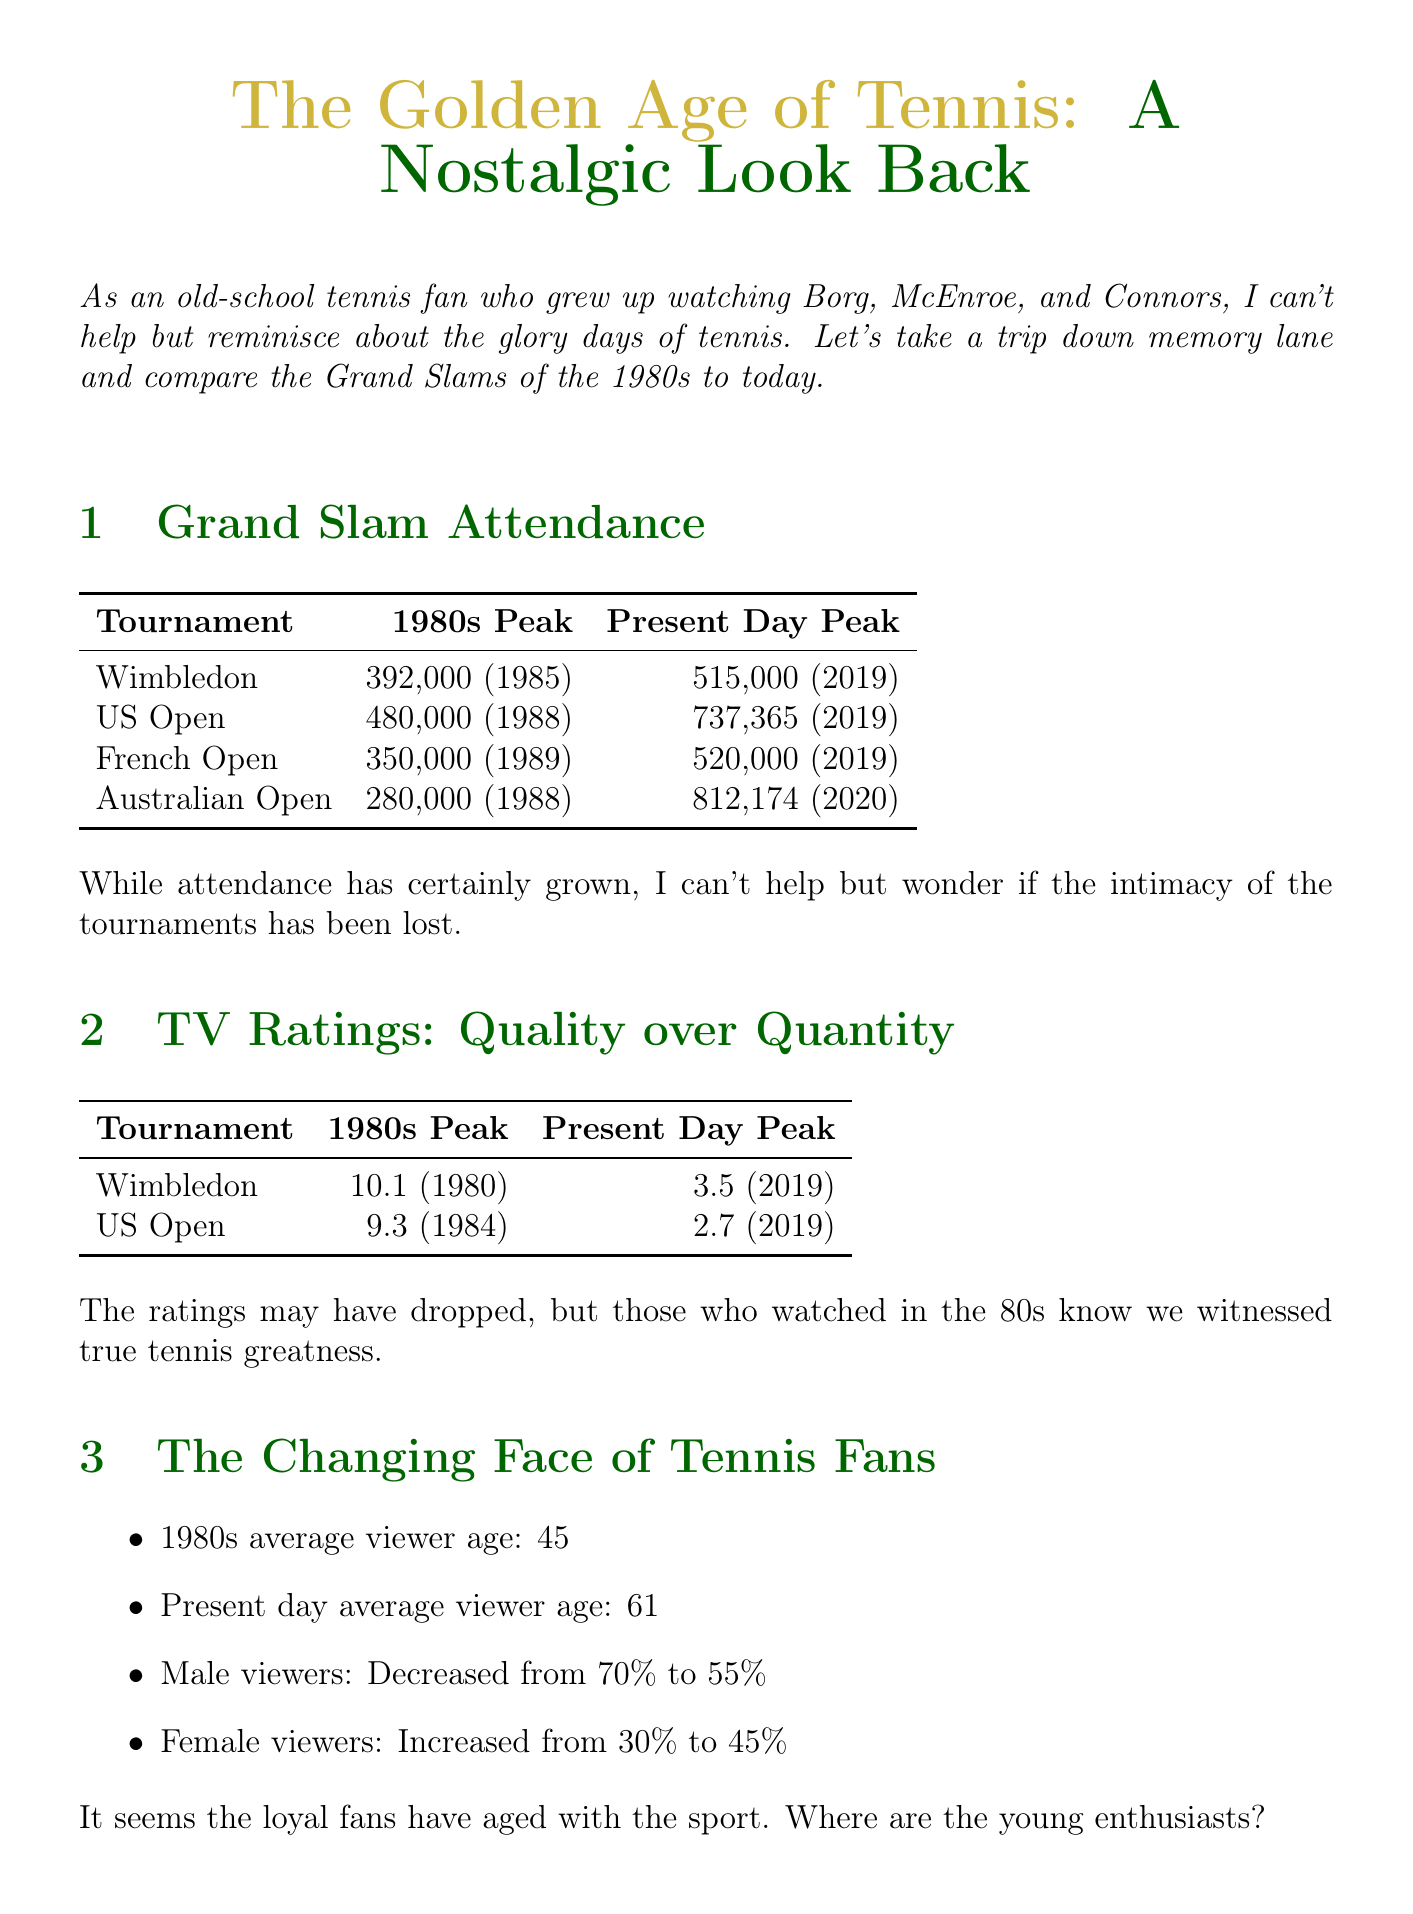What was the peak attendance at Wimbledon in 1985? The peak attendance at Wimbledon in 1985 was 392,000.
Answer: 392,000 What demographic shift occurred in male viewer percentage from the 1980s to present day? The male viewer percentage decreased from 70% in the 1980s to 55% in the present day.
Answer: Decreased to 55% Which match had the peak TV rating for Wimbledon in the 1980s? The peak TV rating for Wimbledon was 10.1 for the match Borg vs McEnroe final in 1980.
Answer: Borg vs McEnroe final What was the average attendance at the US Open in the present day? The average attendance at the US Open in the present day is 720,000.
Answer: 720,000 What are the primary channels used for marketing in the present day? The primary marketing channels in the present day include social media, streaming platforms, and mobile apps.
Answer: Social media Which iconic player was known for the epic tiebreaker at Wimbledon in 1980? The iconic player known for the epic tiebreaker at Wimbledon in 1980 was Borg.
Answer: Borg What was the average viewer age in the 1980s? The average viewer age in the 1980s was 45.
Answer: 45 What key messaging was emphasized in 1980s marketing strategies? The key messaging included rivalry between top players, tradition and prestige of Grand Slams, and national pride in home country players.
Answer: Rivalry between top players When was the peak attendance at the Australian Open? The peak attendance at the Australian Open was in 2020, with 812,174 attendees.
Answer: 812,174 